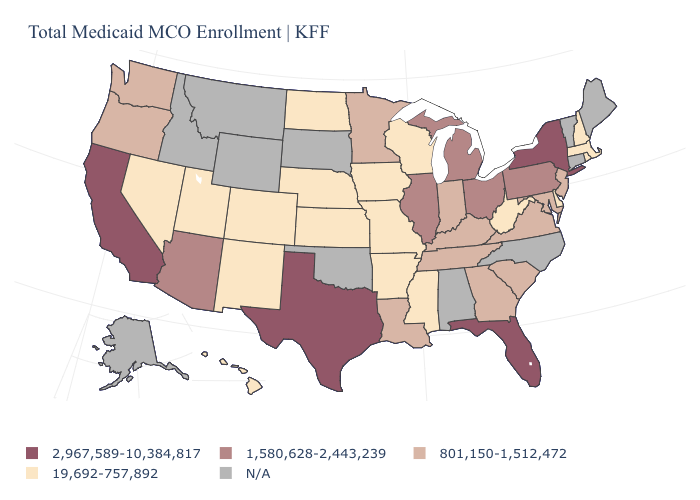Does the map have missing data?
Give a very brief answer. Yes. Among the states that border Montana , which have the highest value?
Short answer required. North Dakota. Name the states that have a value in the range N/A?
Keep it brief. Alabama, Alaska, Connecticut, Idaho, Maine, Montana, North Carolina, Oklahoma, South Dakota, Vermont, Wyoming. Which states have the lowest value in the Northeast?
Short answer required. Massachusetts, New Hampshire, Rhode Island. What is the value of Maine?
Write a very short answer. N/A. Among the states that border Pennsylvania , which have the lowest value?
Give a very brief answer. Delaware, West Virginia. Does the first symbol in the legend represent the smallest category?
Concise answer only. No. Does New Hampshire have the highest value in the USA?
Answer briefly. No. Does the first symbol in the legend represent the smallest category?
Keep it brief. No. What is the highest value in the USA?
Write a very short answer. 2,967,589-10,384,817. How many symbols are there in the legend?
Answer briefly. 5. Name the states that have a value in the range 1,580,628-2,443,239?
Keep it brief. Arizona, Illinois, Michigan, Ohio, Pennsylvania. Does Pennsylvania have the lowest value in the Northeast?
Answer briefly. No. What is the value of Alaska?
Give a very brief answer. N/A. Name the states that have a value in the range 801,150-1,512,472?
Write a very short answer. Georgia, Indiana, Kentucky, Louisiana, Maryland, Minnesota, New Jersey, Oregon, South Carolina, Tennessee, Virginia, Washington. 